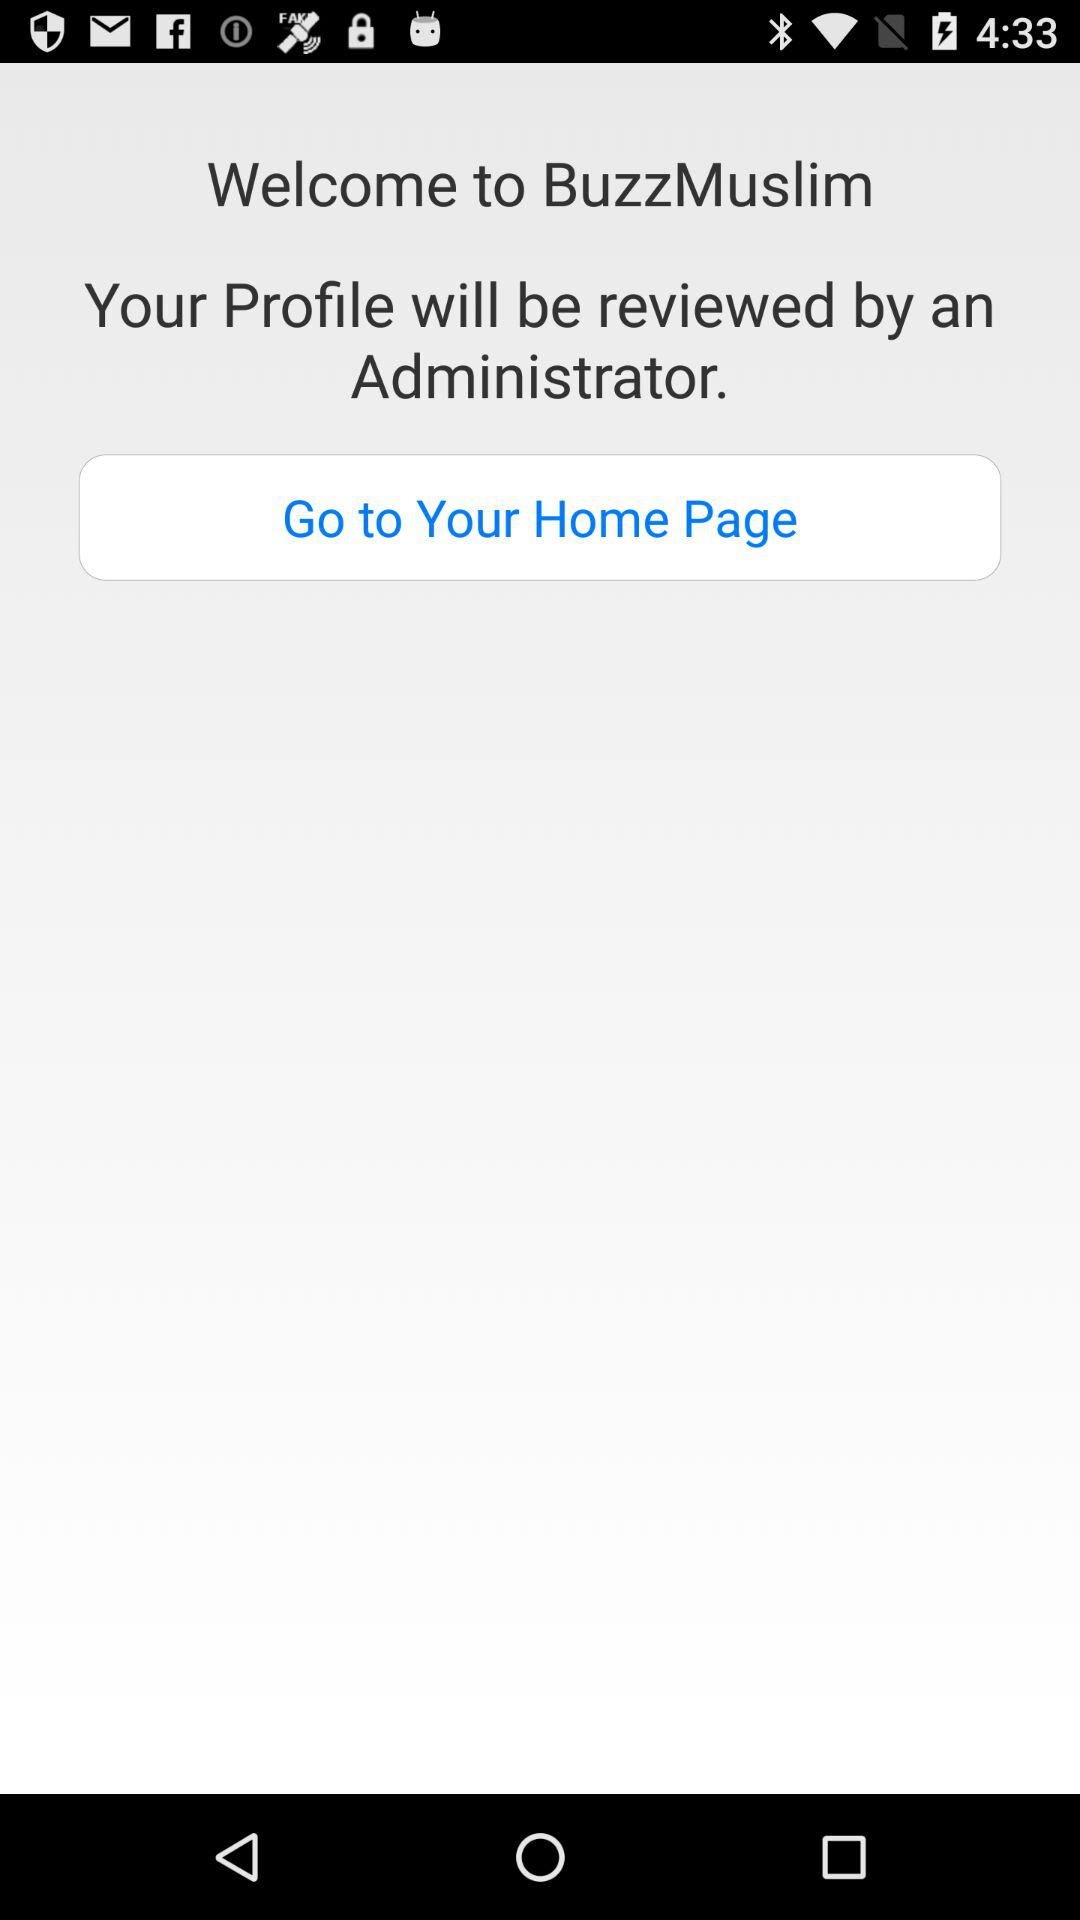What is the app name? The app name is "BuzzMuslim". 